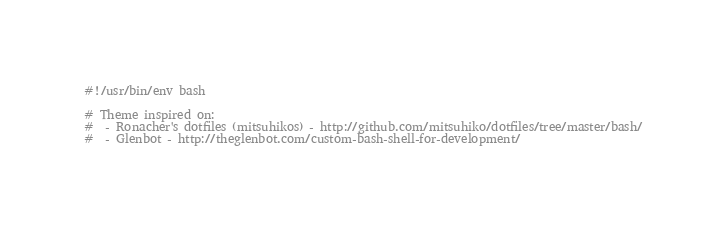Convert code to text. <code><loc_0><loc_0><loc_500><loc_500><_Bash_>#!/usr/bin/env bash

# Theme inspired on:
#  - Ronacher's dotfiles (mitsuhikos) - http://github.com/mitsuhiko/dotfiles/tree/master/bash/
#  - Glenbot - http://theglenbot.com/custom-bash-shell-for-development/</code> 